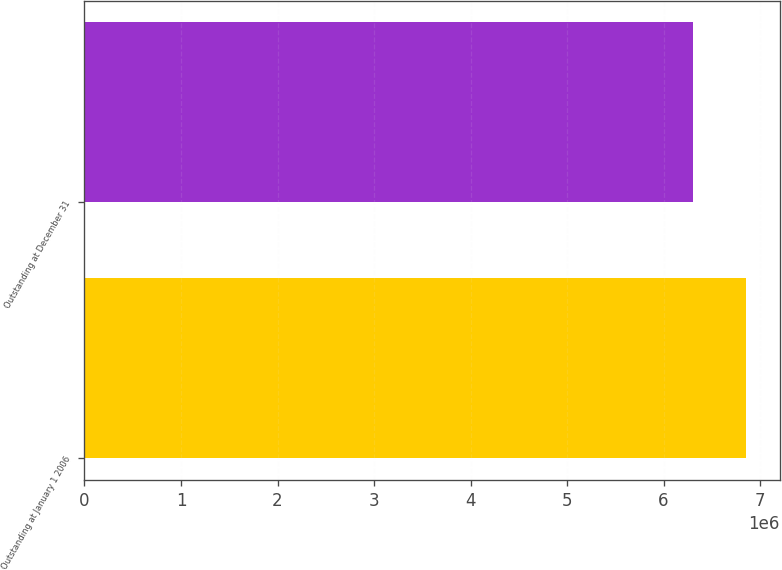Convert chart to OTSL. <chart><loc_0><loc_0><loc_500><loc_500><bar_chart><fcel>Outstanding at January 1 2006<fcel>Outstanding at December 31<nl><fcel>6.85813e+06<fcel>6.30755e+06<nl></chart> 